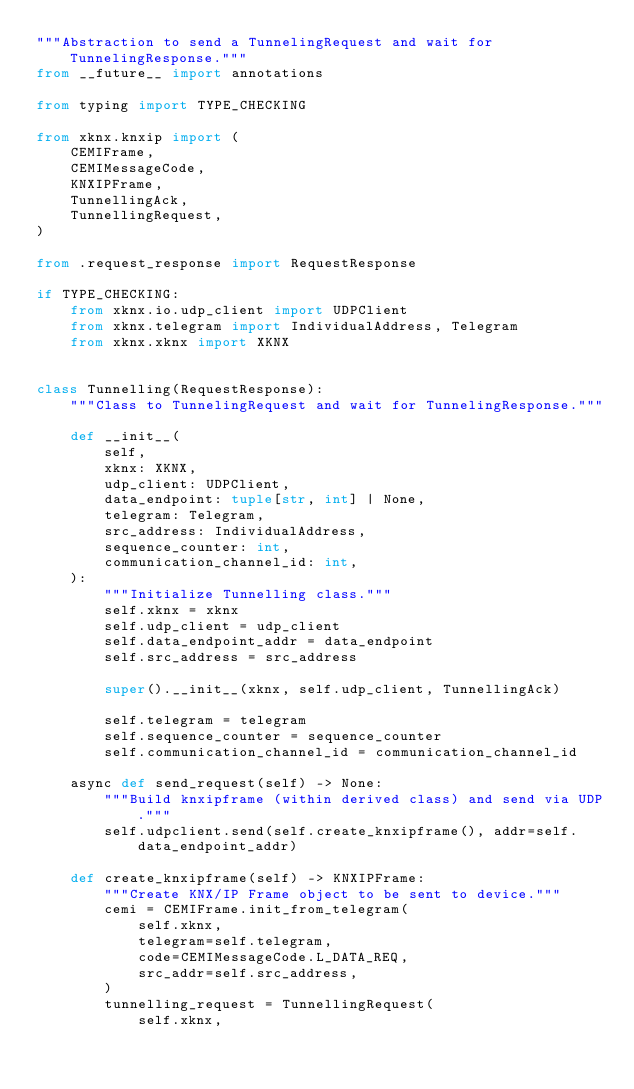Convert code to text. <code><loc_0><loc_0><loc_500><loc_500><_Python_>"""Abstraction to send a TunnelingRequest and wait for TunnelingResponse."""
from __future__ import annotations

from typing import TYPE_CHECKING

from xknx.knxip import (
    CEMIFrame,
    CEMIMessageCode,
    KNXIPFrame,
    TunnellingAck,
    TunnellingRequest,
)

from .request_response import RequestResponse

if TYPE_CHECKING:
    from xknx.io.udp_client import UDPClient
    from xknx.telegram import IndividualAddress, Telegram
    from xknx.xknx import XKNX


class Tunnelling(RequestResponse):
    """Class to TunnelingRequest and wait for TunnelingResponse."""

    def __init__(
        self,
        xknx: XKNX,
        udp_client: UDPClient,
        data_endpoint: tuple[str, int] | None,
        telegram: Telegram,
        src_address: IndividualAddress,
        sequence_counter: int,
        communication_channel_id: int,
    ):
        """Initialize Tunnelling class."""
        self.xknx = xknx
        self.udp_client = udp_client
        self.data_endpoint_addr = data_endpoint
        self.src_address = src_address

        super().__init__(xknx, self.udp_client, TunnellingAck)

        self.telegram = telegram
        self.sequence_counter = sequence_counter
        self.communication_channel_id = communication_channel_id

    async def send_request(self) -> None:
        """Build knxipframe (within derived class) and send via UDP."""
        self.udpclient.send(self.create_knxipframe(), addr=self.data_endpoint_addr)

    def create_knxipframe(self) -> KNXIPFrame:
        """Create KNX/IP Frame object to be sent to device."""
        cemi = CEMIFrame.init_from_telegram(
            self.xknx,
            telegram=self.telegram,
            code=CEMIMessageCode.L_DATA_REQ,
            src_addr=self.src_address,
        )
        tunnelling_request = TunnellingRequest(
            self.xknx,</code> 